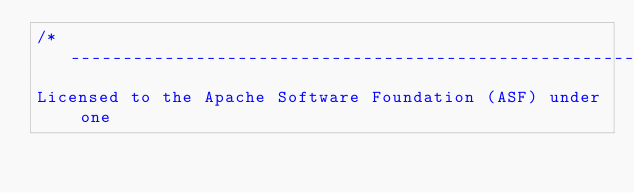<code> <loc_0><loc_0><loc_500><loc_500><_C_>/*-----------------------------------------------------------------------
Licensed to the Apache Software Foundation (ASF) under one</code> 